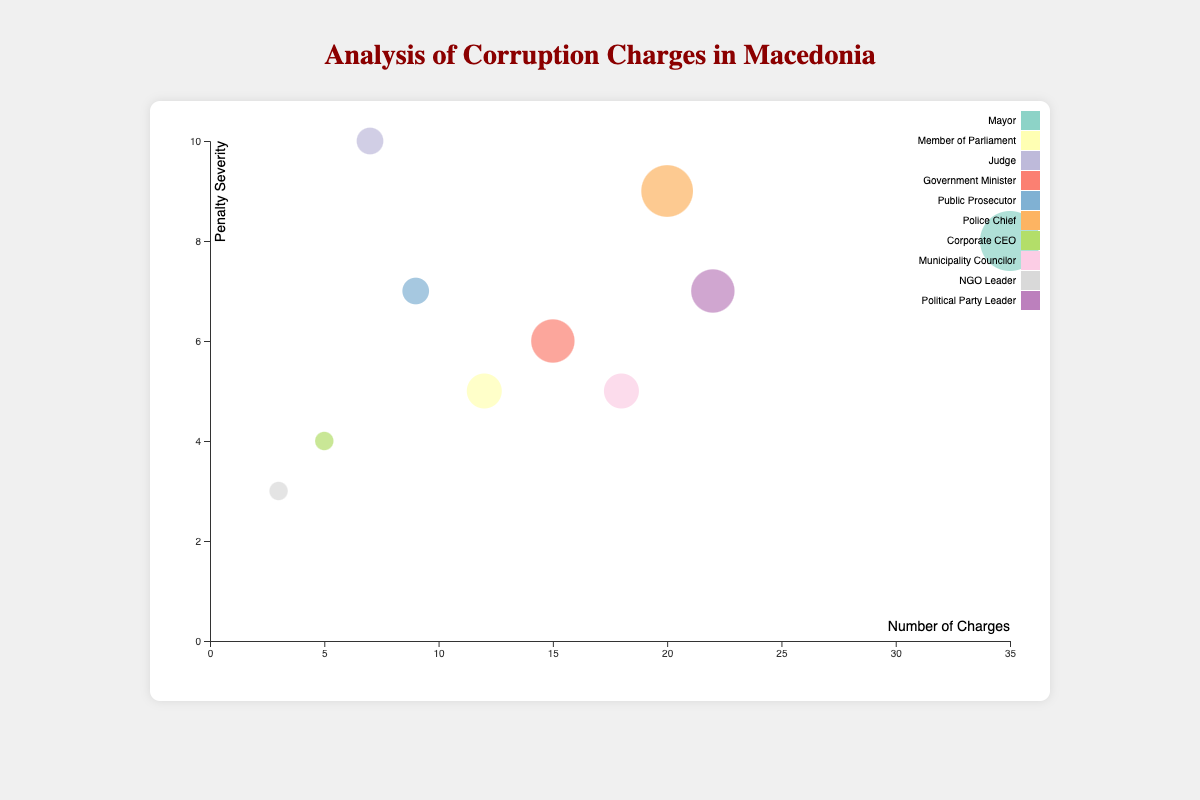What is the title of the chart? The title is displayed prominently at the top of the chart. It is written in larger and bold font, making it easily recognizable.
Answer: Analysis of Corruption Charges in Macedonia Which axis represents the number of charges? The x-axis at the bottom of the chart, labeled "Number of Charges," represents the number of charges.
Answer: X-axis How many positions have a penalty severity greater than 8? By checking the penalty severity values on the y-axis and counting the data points above 8, we find that the "Mayor," "Judge," and "Police Chief" positions have penalty severities greater than 8.
Answer: 3 What is the position with the highest number of charges? By observing the positions of all data points along the x-axis, the point furthest to the right represents the highest number of charges, which corresponds to the "Mayor."
Answer: Mayor Which position had the lowest number of charges and what was the penalty severity for this position? The smallest x-axis value in the chart corresponds to "NGO Leader," and according to the data, its penalty severity is 3, as shown vertically on the y-axis.
Answer: NGO Leader with penalty severity of 3 Calculate the average penalty severity for the positions "Government Minister" and "Political Party Leader." The penalty severity for "Government Minister" is 6 and for "Political Party Leader" is 7. Average = (6 + 7) / 2 = 6.5.
Answer: 6.5 Which position has the largest bubble and how many cases does it represent? The size of each bubble represents the case count. The largest bubble corresponds to the "Mayor" with a case count of 6, as visually apparent from its relative size.
Answer: Mayor with 6 cases Compare the charges between "Member of Parliament" and "Municipality Councilor." Which one has more charges? By locating both data points along the x-axis, "Municipality Councilor" has an x-axis value of 18, while "Member of Parliament" has 12, indicating the Councilor has more charges.
Answer: Municipality Councilor Which position has a case count of 1 and how severe is its penalty? By identifying the smallest bubbles and referencing their positions, both "NGO Leader" and "Corporate CEO" have a case count of 1. Their penalty severities are 3 and 4 respectively.
Answer: NGO Leader (penalty severity: 3), Corporate CEO (penalty severity: 4) Rank the top three positions with the highest number of charges in descending order. First, visually identify and compare the x-axis values: "Mayor" (35), "Political Party Leader" (22), and "Police Chief" (20), then arrange them.
Answer: Mayor, Political Party Leader, Police Chief 